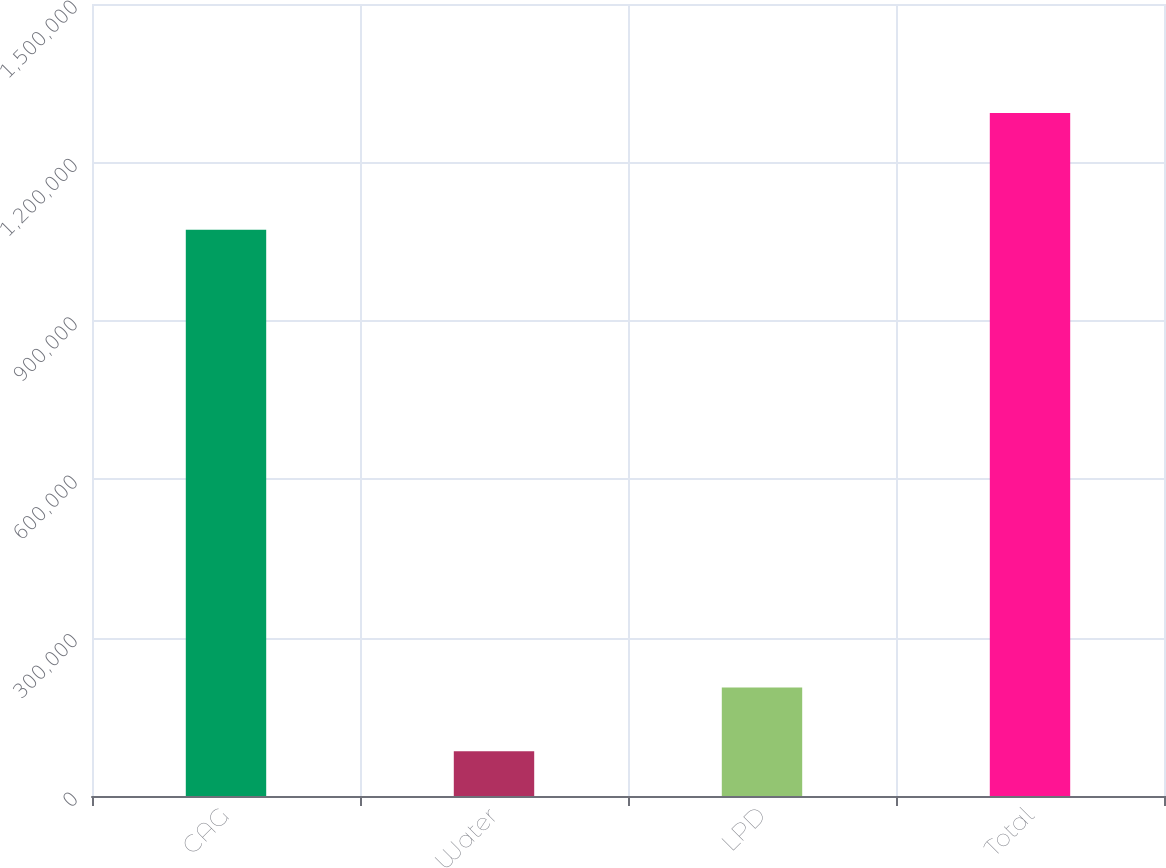<chart> <loc_0><loc_0><loc_500><loc_500><bar_chart><fcel>CAG<fcel>Water<fcel>LPD<fcel>Total<nl><fcel>1.07221e+06<fcel>84680<fcel>205546<fcel>1.29334e+06<nl></chart> 